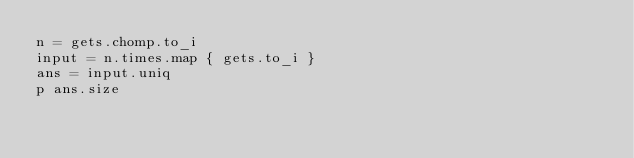Convert code to text. <code><loc_0><loc_0><loc_500><loc_500><_Ruby_>n = gets.chomp.to_i
input = n.times.map { gets.to_i }
ans = input.uniq
p ans.size
</code> 